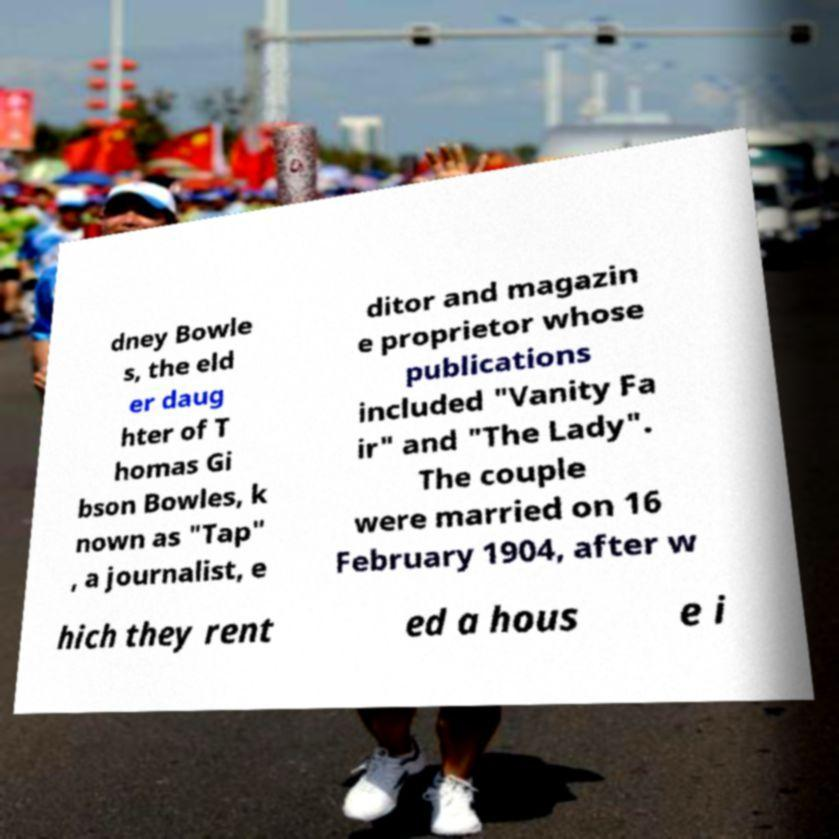For documentation purposes, I need the text within this image transcribed. Could you provide that? dney Bowle s, the eld er daug hter of T homas Gi bson Bowles, k nown as "Tap" , a journalist, e ditor and magazin e proprietor whose publications included "Vanity Fa ir" and "The Lady". The couple were married on 16 February 1904, after w hich they rent ed a hous e i 